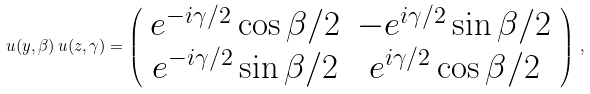Convert formula to latex. <formula><loc_0><loc_0><loc_500><loc_500>u ( { y } , \beta ) \, u ( { z } , \gamma ) = \left ( \begin{array} { c c } e ^ { - i \gamma / 2 } \cos \beta / 2 & - e ^ { i \gamma / 2 } \sin \beta / 2 \\ e ^ { - i \gamma / 2 } \sin \beta / 2 & e ^ { i \gamma / 2 } \cos \beta / 2 \end{array} \right ) \, ,</formula> 